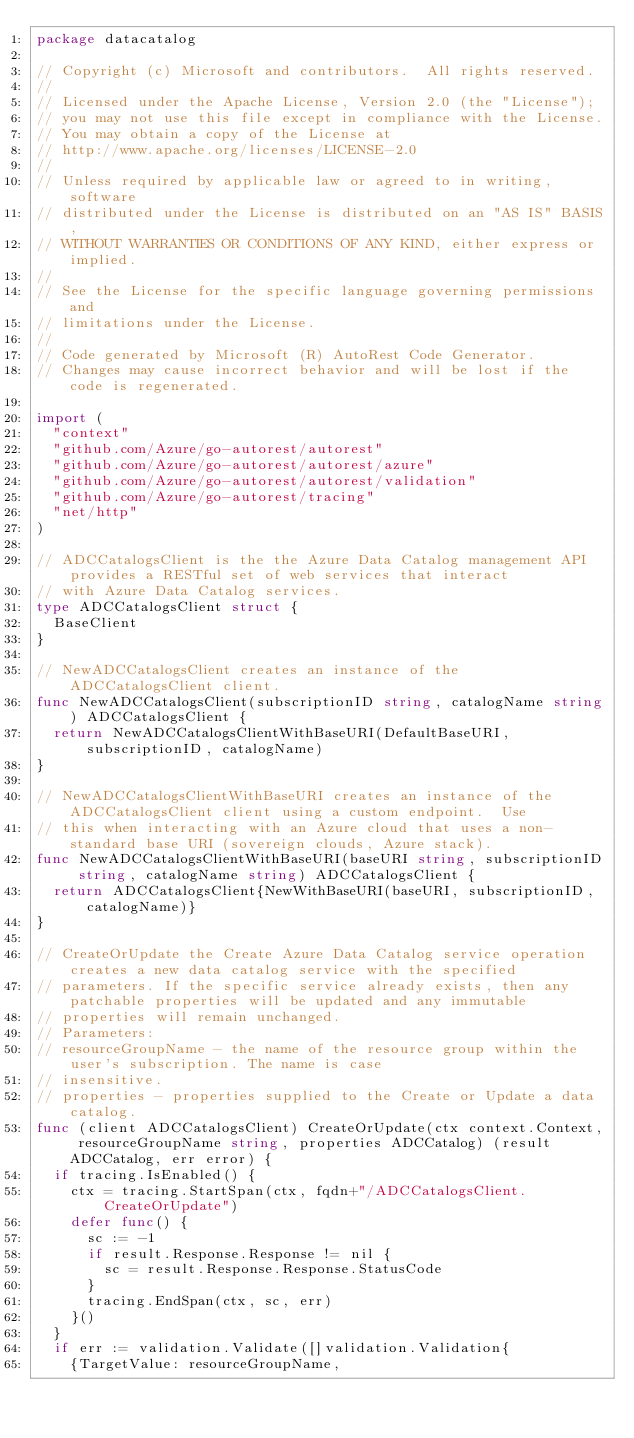<code> <loc_0><loc_0><loc_500><loc_500><_Go_>package datacatalog

// Copyright (c) Microsoft and contributors.  All rights reserved.
//
// Licensed under the Apache License, Version 2.0 (the "License");
// you may not use this file except in compliance with the License.
// You may obtain a copy of the License at
// http://www.apache.org/licenses/LICENSE-2.0
//
// Unless required by applicable law or agreed to in writing, software
// distributed under the License is distributed on an "AS IS" BASIS,
// WITHOUT WARRANTIES OR CONDITIONS OF ANY KIND, either express or implied.
//
// See the License for the specific language governing permissions and
// limitations under the License.
//
// Code generated by Microsoft (R) AutoRest Code Generator.
// Changes may cause incorrect behavior and will be lost if the code is regenerated.

import (
	"context"
	"github.com/Azure/go-autorest/autorest"
	"github.com/Azure/go-autorest/autorest/azure"
	"github.com/Azure/go-autorest/autorest/validation"
	"github.com/Azure/go-autorest/tracing"
	"net/http"
)

// ADCCatalogsClient is the the Azure Data Catalog management API provides a RESTful set of web services that interact
// with Azure Data Catalog services.
type ADCCatalogsClient struct {
	BaseClient
}

// NewADCCatalogsClient creates an instance of the ADCCatalogsClient client.
func NewADCCatalogsClient(subscriptionID string, catalogName string) ADCCatalogsClient {
	return NewADCCatalogsClientWithBaseURI(DefaultBaseURI, subscriptionID, catalogName)
}

// NewADCCatalogsClientWithBaseURI creates an instance of the ADCCatalogsClient client using a custom endpoint.  Use
// this when interacting with an Azure cloud that uses a non-standard base URI (sovereign clouds, Azure stack).
func NewADCCatalogsClientWithBaseURI(baseURI string, subscriptionID string, catalogName string) ADCCatalogsClient {
	return ADCCatalogsClient{NewWithBaseURI(baseURI, subscriptionID, catalogName)}
}

// CreateOrUpdate the Create Azure Data Catalog service operation creates a new data catalog service with the specified
// parameters. If the specific service already exists, then any patchable properties will be updated and any immutable
// properties will remain unchanged.
// Parameters:
// resourceGroupName - the name of the resource group within the user's subscription. The name is case
// insensitive.
// properties - properties supplied to the Create or Update a data catalog.
func (client ADCCatalogsClient) CreateOrUpdate(ctx context.Context, resourceGroupName string, properties ADCCatalog) (result ADCCatalog, err error) {
	if tracing.IsEnabled() {
		ctx = tracing.StartSpan(ctx, fqdn+"/ADCCatalogsClient.CreateOrUpdate")
		defer func() {
			sc := -1
			if result.Response.Response != nil {
				sc = result.Response.Response.StatusCode
			}
			tracing.EndSpan(ctx, sc, err)
		}()
	}
	if err := validation.Validate([]validation.Validation{
		{TargetValue: resourceGroupName,</code> 